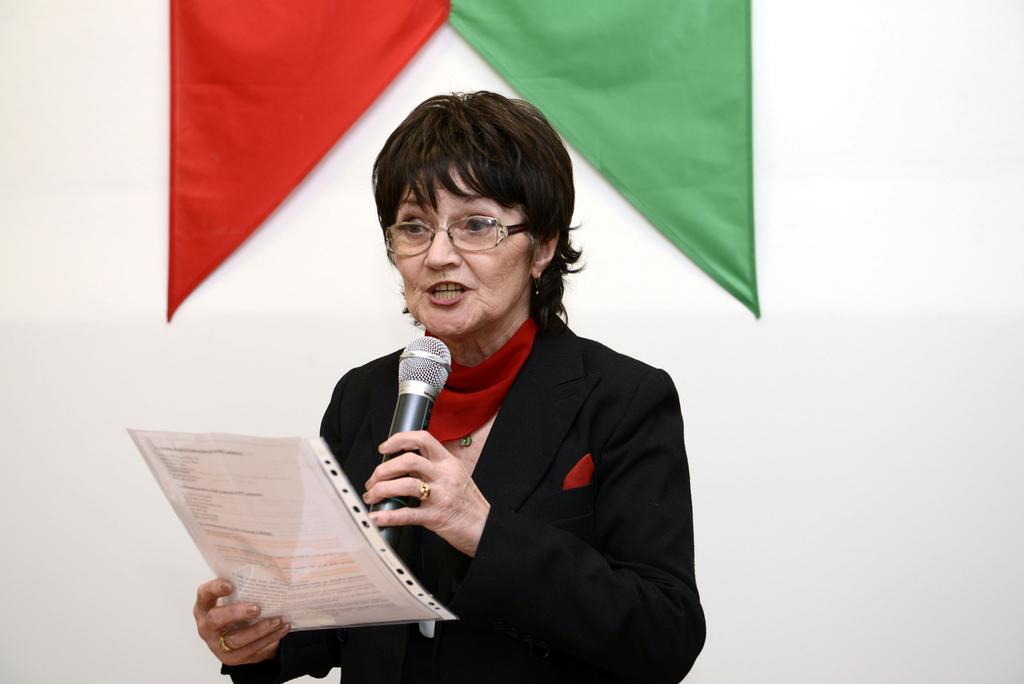Who is the main subject in the image? There is a woman in the image. What is the woman doing in the image? The woman is speaking with the help of a microphone. What is the woman holding in her hand? The woman is holding a paper in her hand. What can be seen in the background of the image? There is a flag visible in the image. What type of curtain is hanging in the background of the image? There is no curtain present in the image. What direction is the woman facing in the image? The provided facts do not specify the direction the woman is facing in the image. 